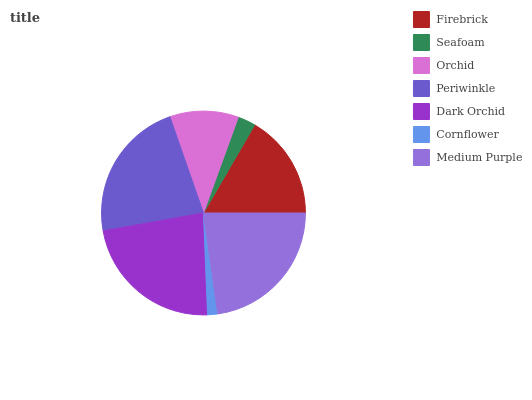Is Cornflower the minimum?
Answer yes or no. Yes. Is Dark Orchid the maximum?
Answer yes or no. Yes. Is Seafoam the minimum?
Answer yes or no. No. Is Seafoam the maximum?
Answer yes or no. No. Is Firebrick greater than Seafoam?
Answer yes or no. Yes. Is Seafoam less than Firebrick?
Answer yes or no. Yes. Is Seafoam greater than Firebrick?
Answer yes or no. No. Is Firebrick less than Seafoam?
Answer yes or no. No. Is Firebrick the high median?
Answer yes or no. Yes. Is Firebrick the low median?
Answer yes or no. Yes. Is Dark Orchid the high median?
Answer yes or no. No. Is Dark Orchid the low median?
Answer yes or no. No. 